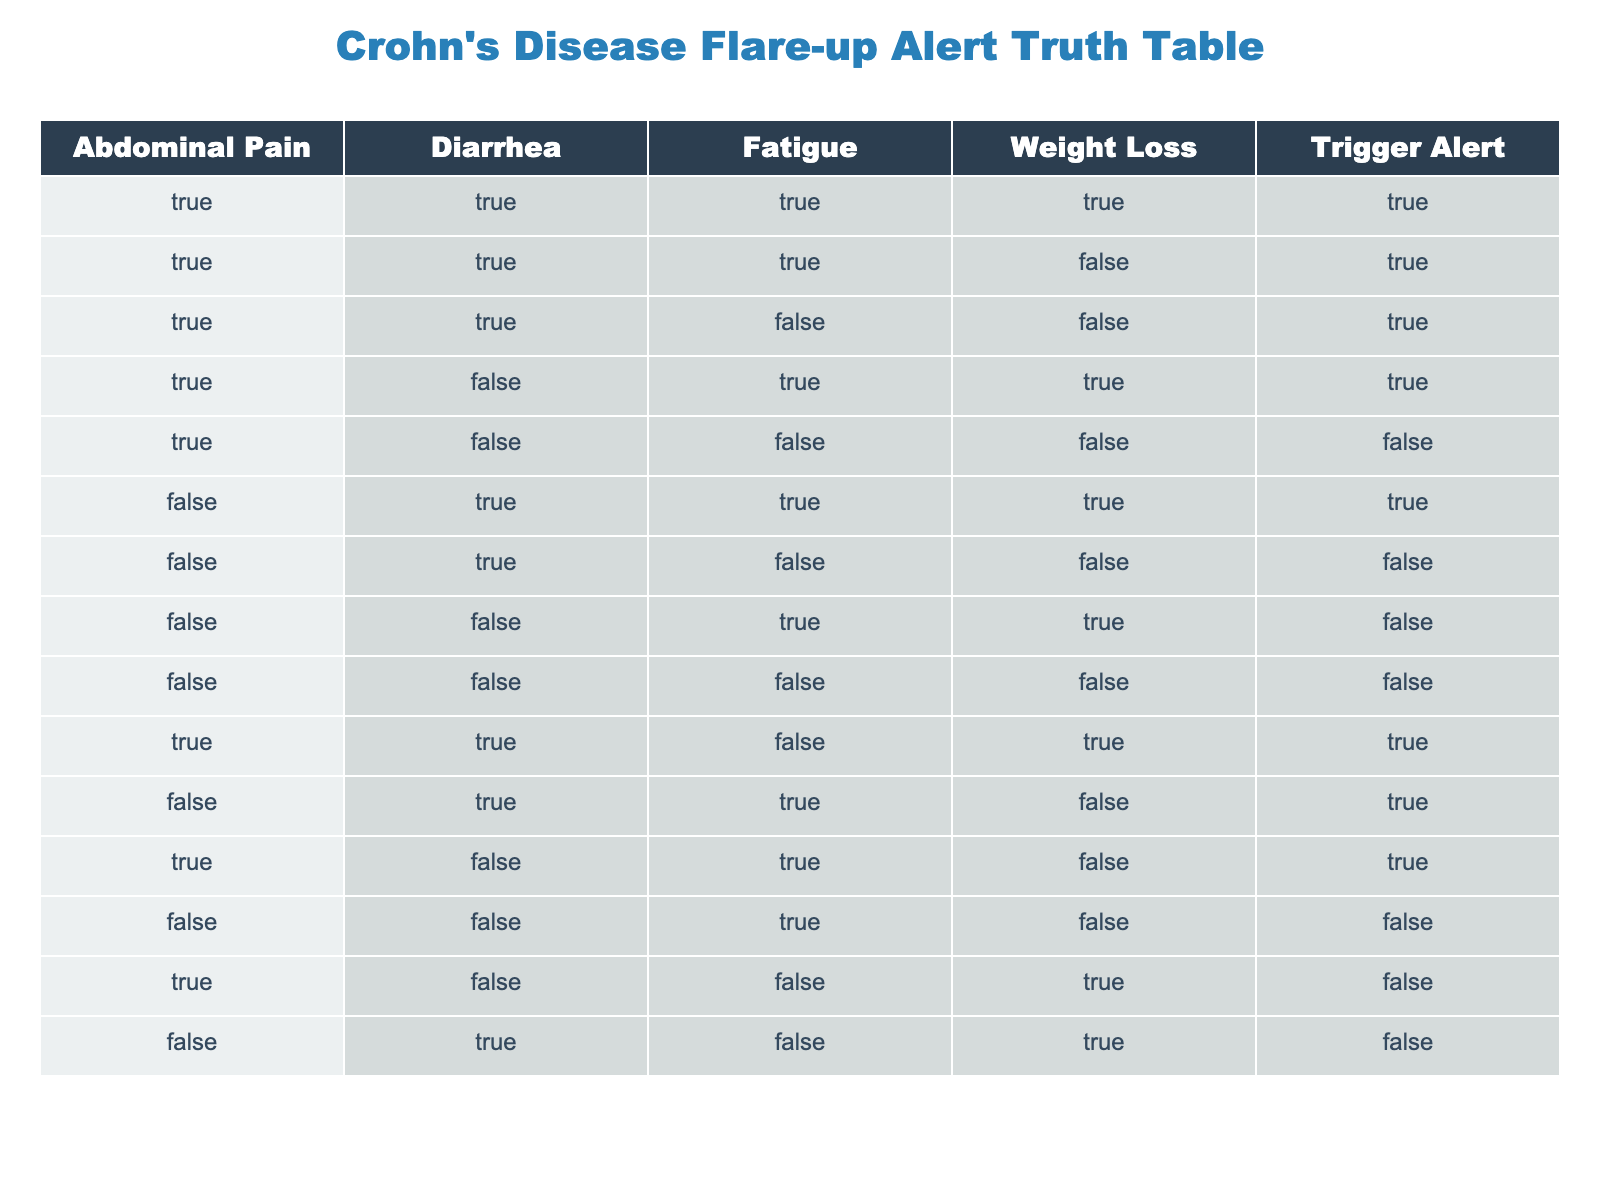What is the total number of entries that trigger an alert? By reviewing the 'Trigger Alert' column in the table, we can count the number of rows where the value is True. There are 8 rows with a True value in the 'Trigger Alert' column.
Answer: 8 How many conditions are associated with a True alert when there is no weight loss? We look for rows where 'Weight Loss' is False and 'Trigger Alert' is True. There are 4 such rows: the first, second, and tenth, so the total count is 3.
Answer: 3 Is abdominal pain alone enough to trigger an alert? We find rows where 'Abdominal Pain' is True, and their corresponding 'Trigger Alert' values. The rows with True abdominal pain show that even without other symptoms, it can trigger alerts. Specifically, there are 6 instances where 'Trigger Alert' is True, even if other symptoms are varied.
Answer: Yes What is the relationship between fatigue and alert triggers? To determine this, we can check how many alerts are triggered with Fatigue True and how many columns show it. We see 5 triggering alerts that have Fatigue as True, but not all instances lead to an alert. However, with other symptoms, Fatigue correlates with several alerts.
Answer: Mostly positive How many combinations lead to an alert without any abdominal pain? We have to check all rows where 'Abdominal Pain' is False and see how many instances show 'Trigger Alert' as True. Upon reviewing, there are 3 such entries that satisfy this condition.
Answer: 3 Is it possible to have fatigue and a trigger alert without diarrhea? We look at rows where 'Fatigue' is True and 'Diarrhea' is False, then check 'Trigger Alert'. The rows would show that fatigue does not guarantee a trigger without diarrhea due to one specific row negating it.
Answer: No Which condition combination provides the highest likelihood of an alarm? We analyze all entries marked with True under 'Trigger Alert', and by aggregation, we find that 'Abdominal Pain', 'Diarrhea', and 'Fatigue' together provide the highest frequency of alarms at 4 instances.
Answer: Abdominal Pain, Diarrhea, Fatigue How many alerts are triggered if only weight loss and fatigue conditions are satisfied? By checking the table's entries where both 'Weight Loss' and 'Fatigue' are True, we can see that only 2 rows satisfy this condition, both of which trigger an alert simultaneously.
Answer: 2 